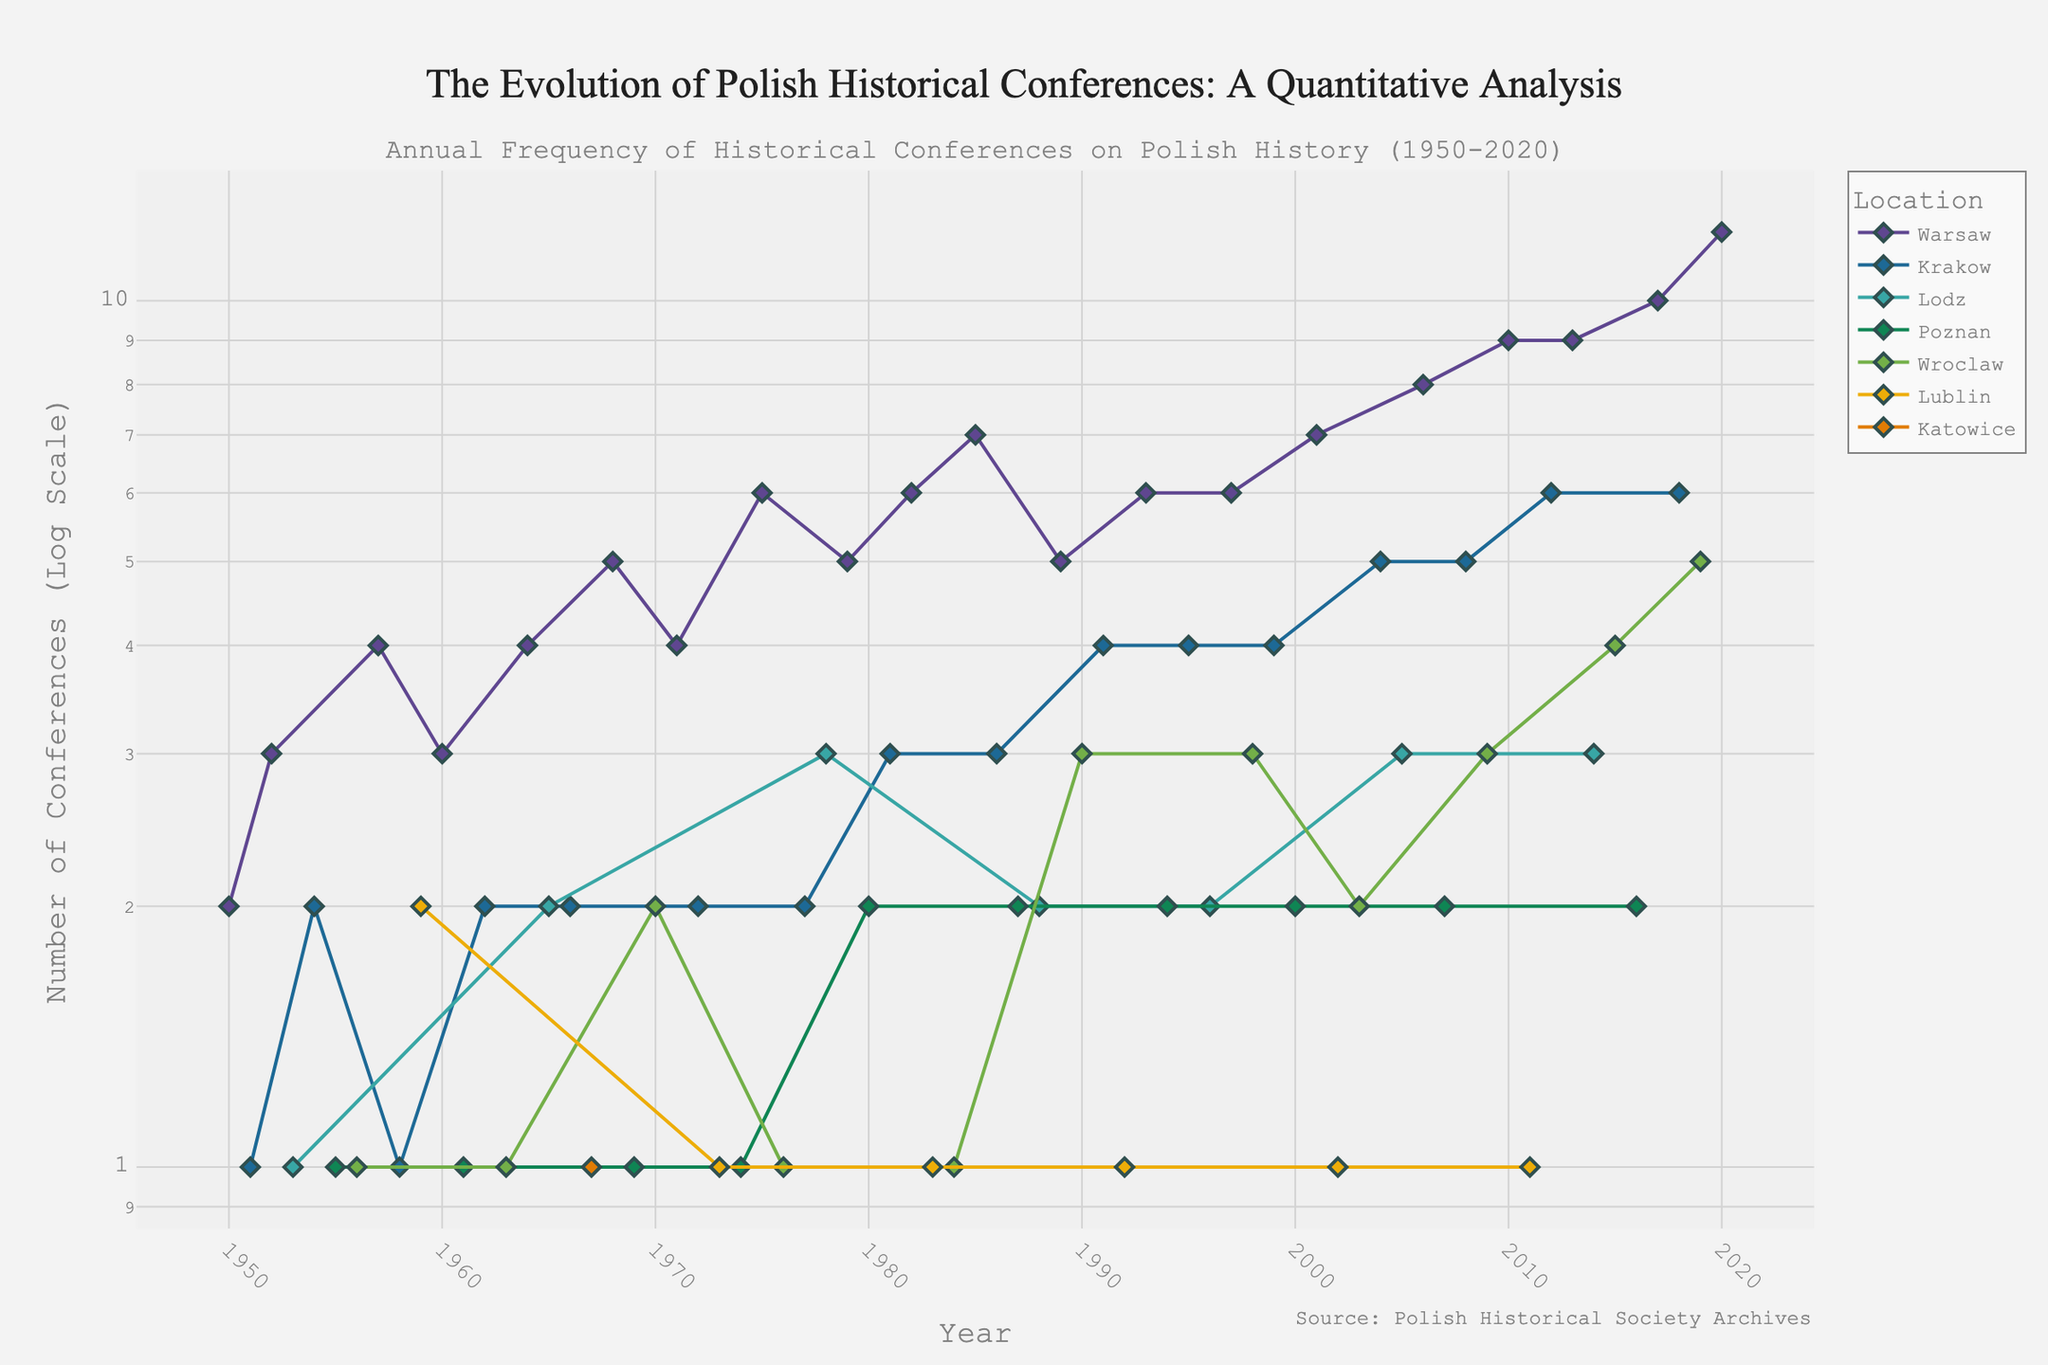What is the title of the plot? The title is usually found at the top of the plot. In this case, it appears to be "The Evolution of Polish Historical Conferences: A Quantitative Analysis". This is visible from the title attribute in the plot layout.
Answer: The Evolution of Polish Historical Conferences: A Quantitative Analysis How many conferences were held in Warsaw in 2020? To find this, look for the data point on the line corresponding to Warsaw in the year 2020. According to the plot, the number of conferences is marked at the highest value on the y-axis for that year.
Answer: 12 Which city held the most conferences in 1982? Examine the data points for different cities on the x-axis corresponding to the year 1982. The city with the highest value on the y-axis held the most conferences.
Answer: Warsaw How does the number of conferences in Krakow in 2012 compare to 2004? Identify the data points for Krakow in the years 2012 and 2004. The y-axis values for these points will show the number of conferences in each year. 2012 had 6 conferences, while 2004 had 5. Therefore, 2012 had more conferences than 2004.
Answer: 2012 had more What is the average number of conferences held in Poznan over the decades 1950-1960? To calculate the average, sum the number of conferences in Poznan from 1950 to 1960 and divide by the number of years. From the data, there are conferences held in the years: 1955, 1961, and 1969, with counts 1, 1, and 1 respectively, totaling 3 conferences over 3 years. So the average is 3/3 = 1.
Answer: 1 What is the trend in the number of conferences in Wroclaw from 2009 to 2015? Look at the data points for Wroclaw from 2009 to 2015. The general trend can be identified by observing whether the line connecting these points is increasing, decreasing, or stable. The points show an increasing trend from 2009 (3 conferences) to 2015 (4 conferences).
Answer: Increasing Which city shows the highest variability in the number of conferences over the entire period? To determine this, compare the fluctuations in the y-axis values for each city's data line across the entire period from 1950 to 2020. Warsaw shows significant variability, ranging from very low around the 1950s to very high in recent years.
Answer: Warsaw What is the difference in the number of conferences held in Lublin in 1959 and 1983? Identify the two data points for Lublin in 1959 and 1983. The values are 2 and 1 respectively. Subtract 1 from 2 to find the difference.
Answer: 1 How many conferences were held in Lodz by the year 1988? Sum the number of conferences held in Lodz from 1950 to 1988. This includes years 1953, 1965, 1978, and 1988 with values 1, 2, 3, and 2 respectively. The total is 1+2+3+2 = 8.
Answer: 8 Describe the overall trend in the number of conferences held in Krakow from 1950 to 2020. Review the entire data line for Krakow from 1950 to 2020. The trend shows an overall increase with more fluctuations and significant spikes in recent decades indicating a higher average number of conferences in the later years compared to the earlier ones.
Answer: Increasing with fluctuations 